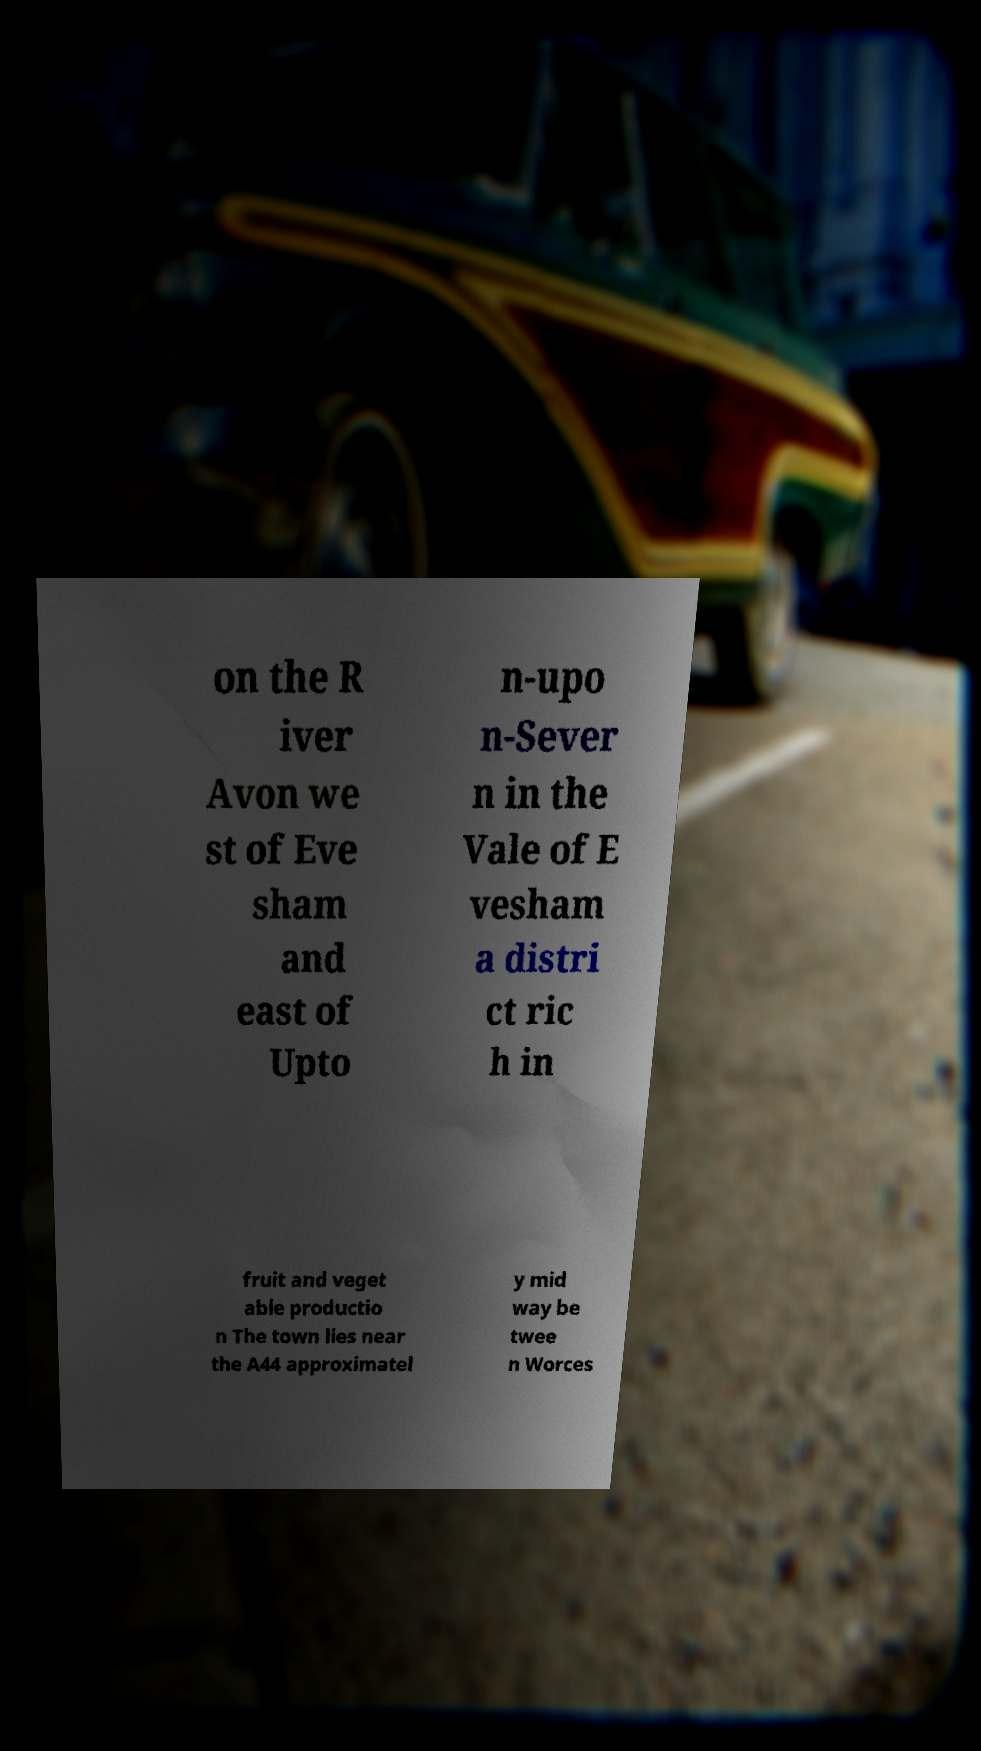I need the written content from this picture converted into text. Can you do that? on the R iver Avon we st of Eve sham and east of Upto n-upo n-Sever n in the Vale of E vesham a distri ct ric h in fruit and veget able productio n The town lies near the A44 approximatel y mid way be twee n Worces 